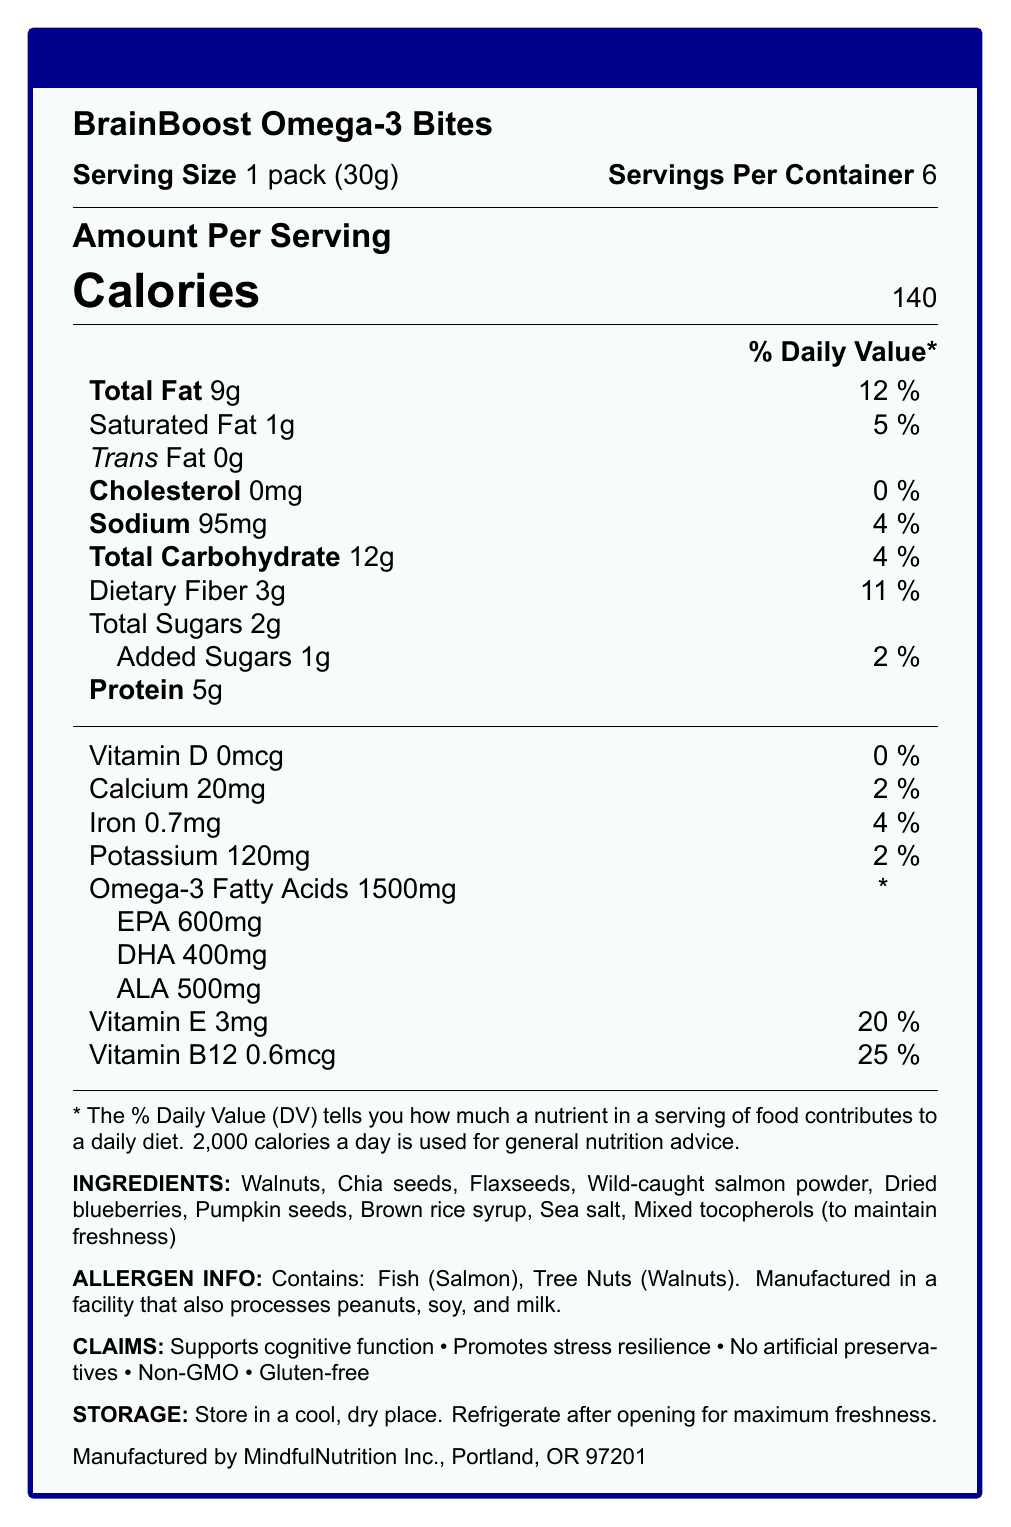what is the serving size? The serving size is clearly listed as "1 pack (30g)" in the nutrition facts.
Answer: 1 pack (30g) how many servings are there per container? The document states that there are 6 servings per container.
Answer: 6 how many calories are in one serving? The document specifies "Calories 140" under the amount per serving section.
Answer: 140 how much total fat is in one serving? Under the % Daily Value section, total fat is listed as "9g".
Answer: 9g what is the daily value percentage for saturated fat per serving? The label indicates that 1g of saturated fat makes up 5% of the daily value.
Answer: 5% what is the total carbohydrate content per serving? A. 10g B. 12g C. 15g The document lists "Total Carbohydrate 12g" in the nutrition facts.
Answer: B which ingredient is included for its freshness-preserving properties? A. Sea salt B. Wild-caught salmon powder C. Mixed tocopherols The ingredient list mentions "Mixed tocopherols (to maintain freshness)."
Answer: C what is the primary function claimed by the product? One of the claims listed is "Supports cognitive function."
Answer: Supports cognitive function does the product contain any artificial preservatives? The claims section specifies "No artificial preservatives."
Answer: No is the product gluten-free? The claims section lists "Gluten-free."
Answer: Yes how much protein does one serving contain? The amount of protein per serving is listed as "5g".
Answer: 5g what percentage of daily value does vitamin B12 contribute in one serving? For vitamin B12, the label shows "25%" daily value.
Answer: 25% how many milligrams of calcium are in one serving? The document lists calcium content as "20mg".
Answer: 20mg what allergen information is provided about this product? The allergen information specifies these two allergens.
Answer: Contains: Fish (Salmon), Tree Nuts (Walnuts). summarize the main features and claims of BrainBoost Omega-3 Bites. This summary encapsulates the purpose, ingredients, nutritional benefits, and claims of the product.
Answer: The product "BrainBoost Omega-3 Bites" is a snack designed for cognitive function support and stress resilience. It contains omega-3 fatty acids (EPA, DHA, ALA), is made from natural ingredients like walnuts and chia seeds, and is free from artificial preservatives and gluten. It has significant nutrients, including proteins, dietary fibers, and vitamins B12 and E, with allergen information explicitly noted. what is the exact amount of iron per serving? The nutrition facts state that iron content is "0.7mg."
Answer: 0.7mg how many grams of omega-3 fatty acids are present per serving? The document lists "Omega-3 Fatty Acids 1500mg" in the nutrition facts.
Answer: 1500mg how much added sugar is in one serving? The label indicates "Added Sugars 1g."
Answer: 1g is the product non-GMO? The claims section mentions "Non-GMO."
Answer: Yes can you determine where the ingredients are sourced from? The document only lists the ingredients but does not provide information on their sources.
Answer: Cannot be determined 